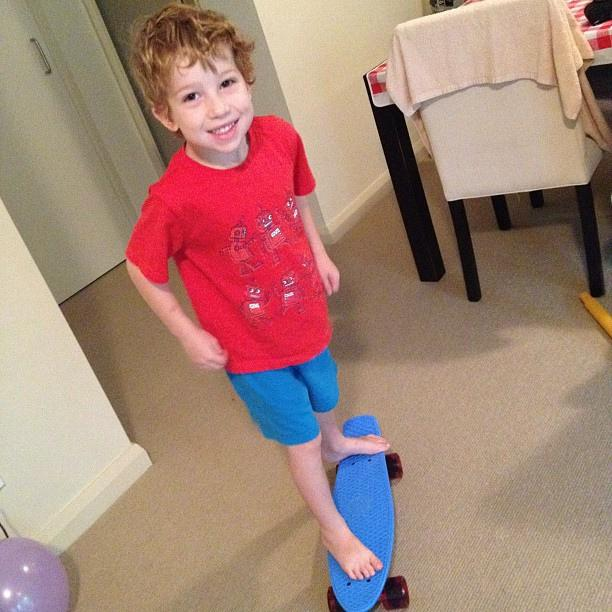The color of the boy's outfit matches the colors of the costume of what super hero?

Choices:
A) batman
B) spider man
C) wolverine
D) iron man spider man 